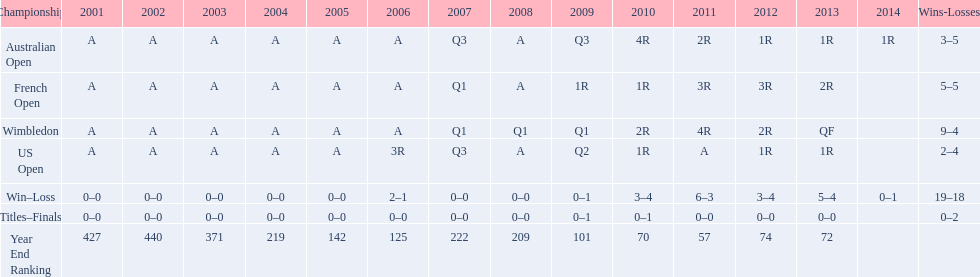What was this players average ranking between 2001 and 2006? 287. 